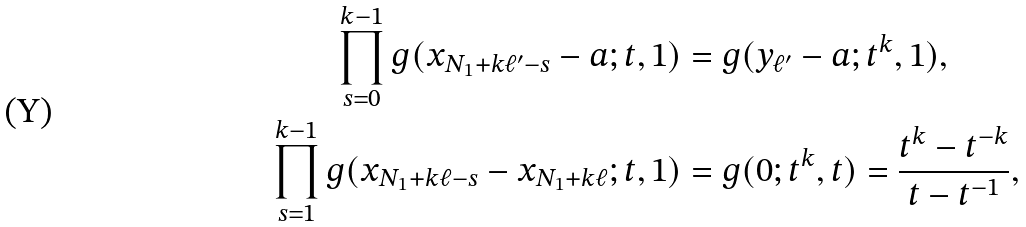<formula> <loc_0><loc_0><loc_500><loc_500>\prod _ { s = 0 } ^ { k - 1 } g ( x _ { N _ { 1 } + k \ell ^ { \prime } - s } - a ; t , 1 ) & = g ( y _ { \ell ^ { \prime } } - a ; t ^ { k } , 1 ) , \\ \prod _ { s = 1 } ^ { k - 1 } g ( x _ { N _ { 1 } + k \ell - s } - x _ { N _ { 1 } + k \ell } ; t , 1 ) & = g ( 0 ; t ^ { k } , t ) = \frac { t ^ { k } - t ^ { - k } } { t - t ^ { - 1 } } ,</formula> 